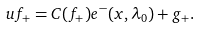Convert formula to latex. <formula><loc_0><loc_0><loc_500><loc_500>u f _ { + } = C ( f _ { + } ) e ^ { - } ( x , \lambda _ { 0 } ) + g _ { + } .</formula> 